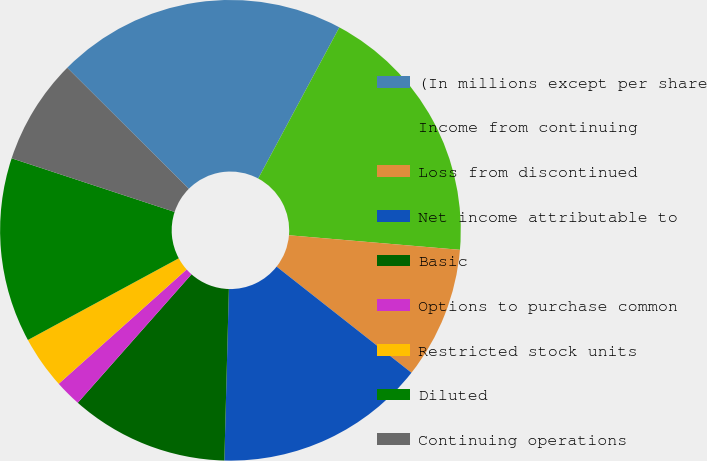Convert chart to OTSL. <chart><loc_0><loc_0><loc_500><loc_500><pie_chart><fcel>(In millions except per share<fcel>Income from continuing<fcel>Loss from discontinued<fcel>Net income attributable to<fcel>Basic<fcel>Options to purchase common<fcel>Restricted stock units<fcel>Diluted<fcel>Continuing operations<nl><fcel>20.37%<fcel>18.51%<fcel>9.26%<fcel>14.81%<fcel>11.11%<fcel>1.86%<fcel>3.71%<fcel>12.96%<fcel>7.41%<nl></chart> 